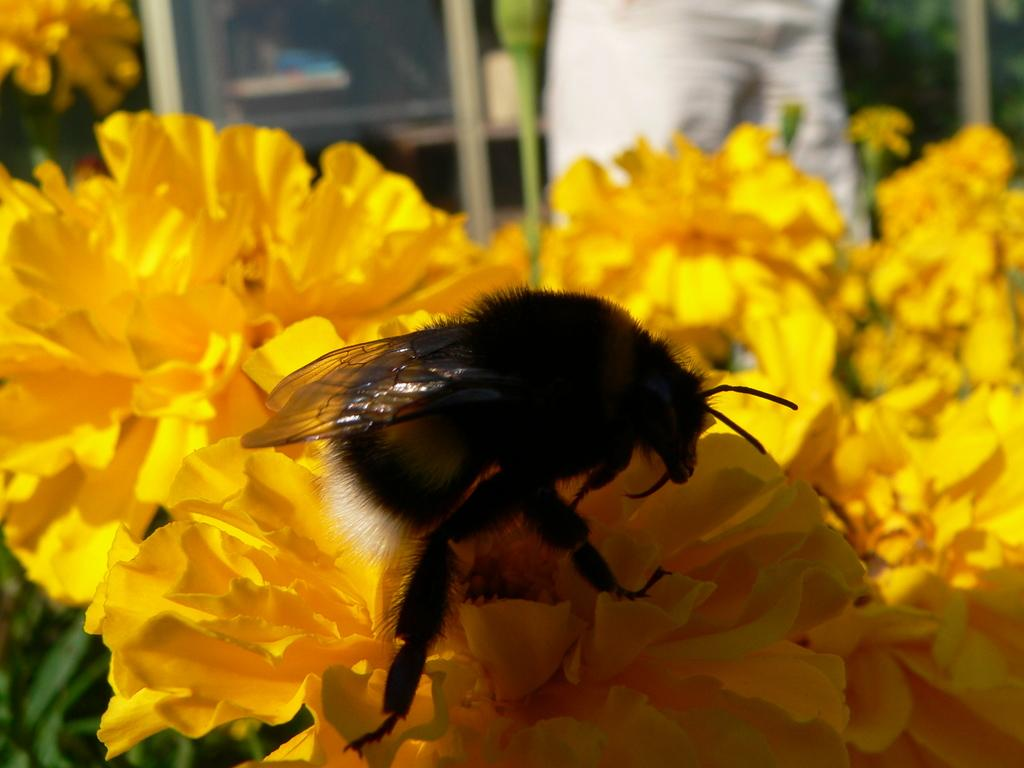What is on the yellow flowers in the image? There is an insect on the yellow flowers in the image. What type of plant is visible in the image? There is a plant in the image. What is the person doing in the image? The person is standing at a door in the image. What type of trade is being conducted in the image? There is no indication of any trade being conducted in the image. Is the person sailing in the image? There is no indication of the person sailing in the image; they are standing at a door. 